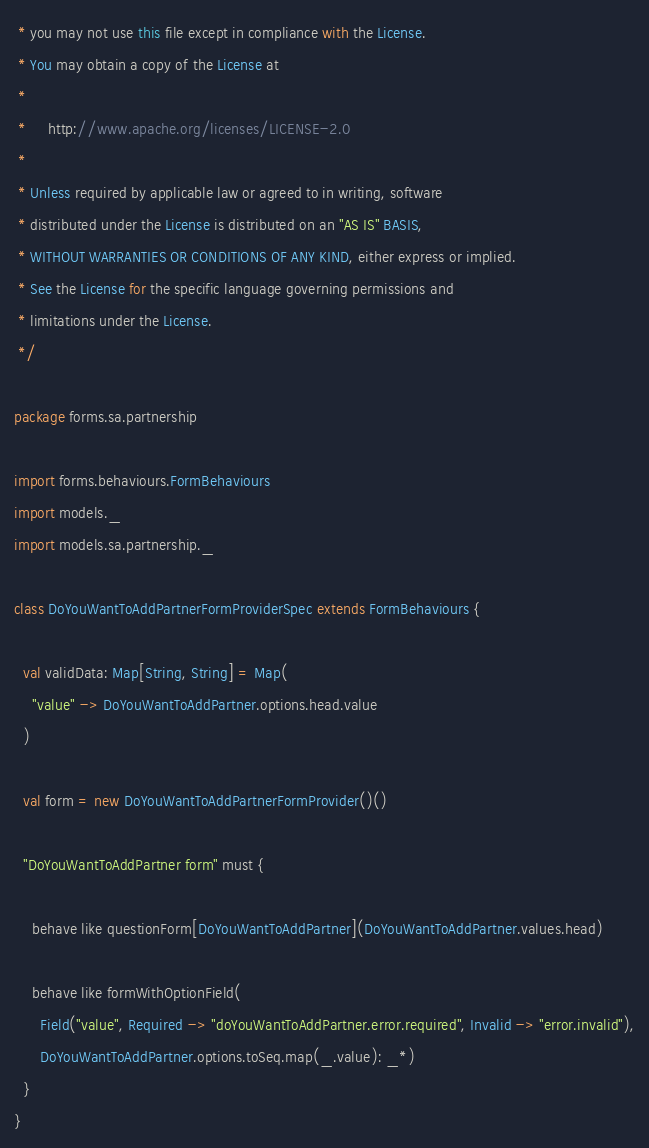Convert code to text. <code><loc_0><loc_0><loc_500><loc_500><_Scala_> * you may not use this file except in compliance with the License.
 * You may obtain a copy of the License at
 *
 *     http://www.apache.org/licenses/LICENSE-2.0
 *
 * Unless required by applicable law or agreed to in writing, software
 * distributed under the License is distributed on an "AS IS" BASIS,
 * WITHOUT WARRANTIES OR CONDITIONS OF ANY KIND, either express or implied.
 * See the License for the specific language governing permissions and
 * limitations under the License.
 */

package forms.sa.partnership

import forms.behaviours.FormBehaviours
import models._
import models.sa.partnership._

class DoYouWantToAddPartnerFormProviderSpec extends FormBehaviours {

  val validData: Map[String, String] = Map(
    "value" -> DoYouWantToAddPartner.options.head.value
  )

  val form = new DoYouWantToAddPartnerFormProvider()()

  "DoYouWantToAddPartner form" must {

    behave like questionForm[DoYouWantToAddPartner](DoYouWantToAddPartner.values.head)

    behave like formWithOptionField(
      Field("value", Required -> "doYouWantToAddPartner.error.required", Invalid -> "error.invalid"),
      DoYouWantToAddPartner.options.toSeq.map(_.value): _*)
  }
}
</code> 